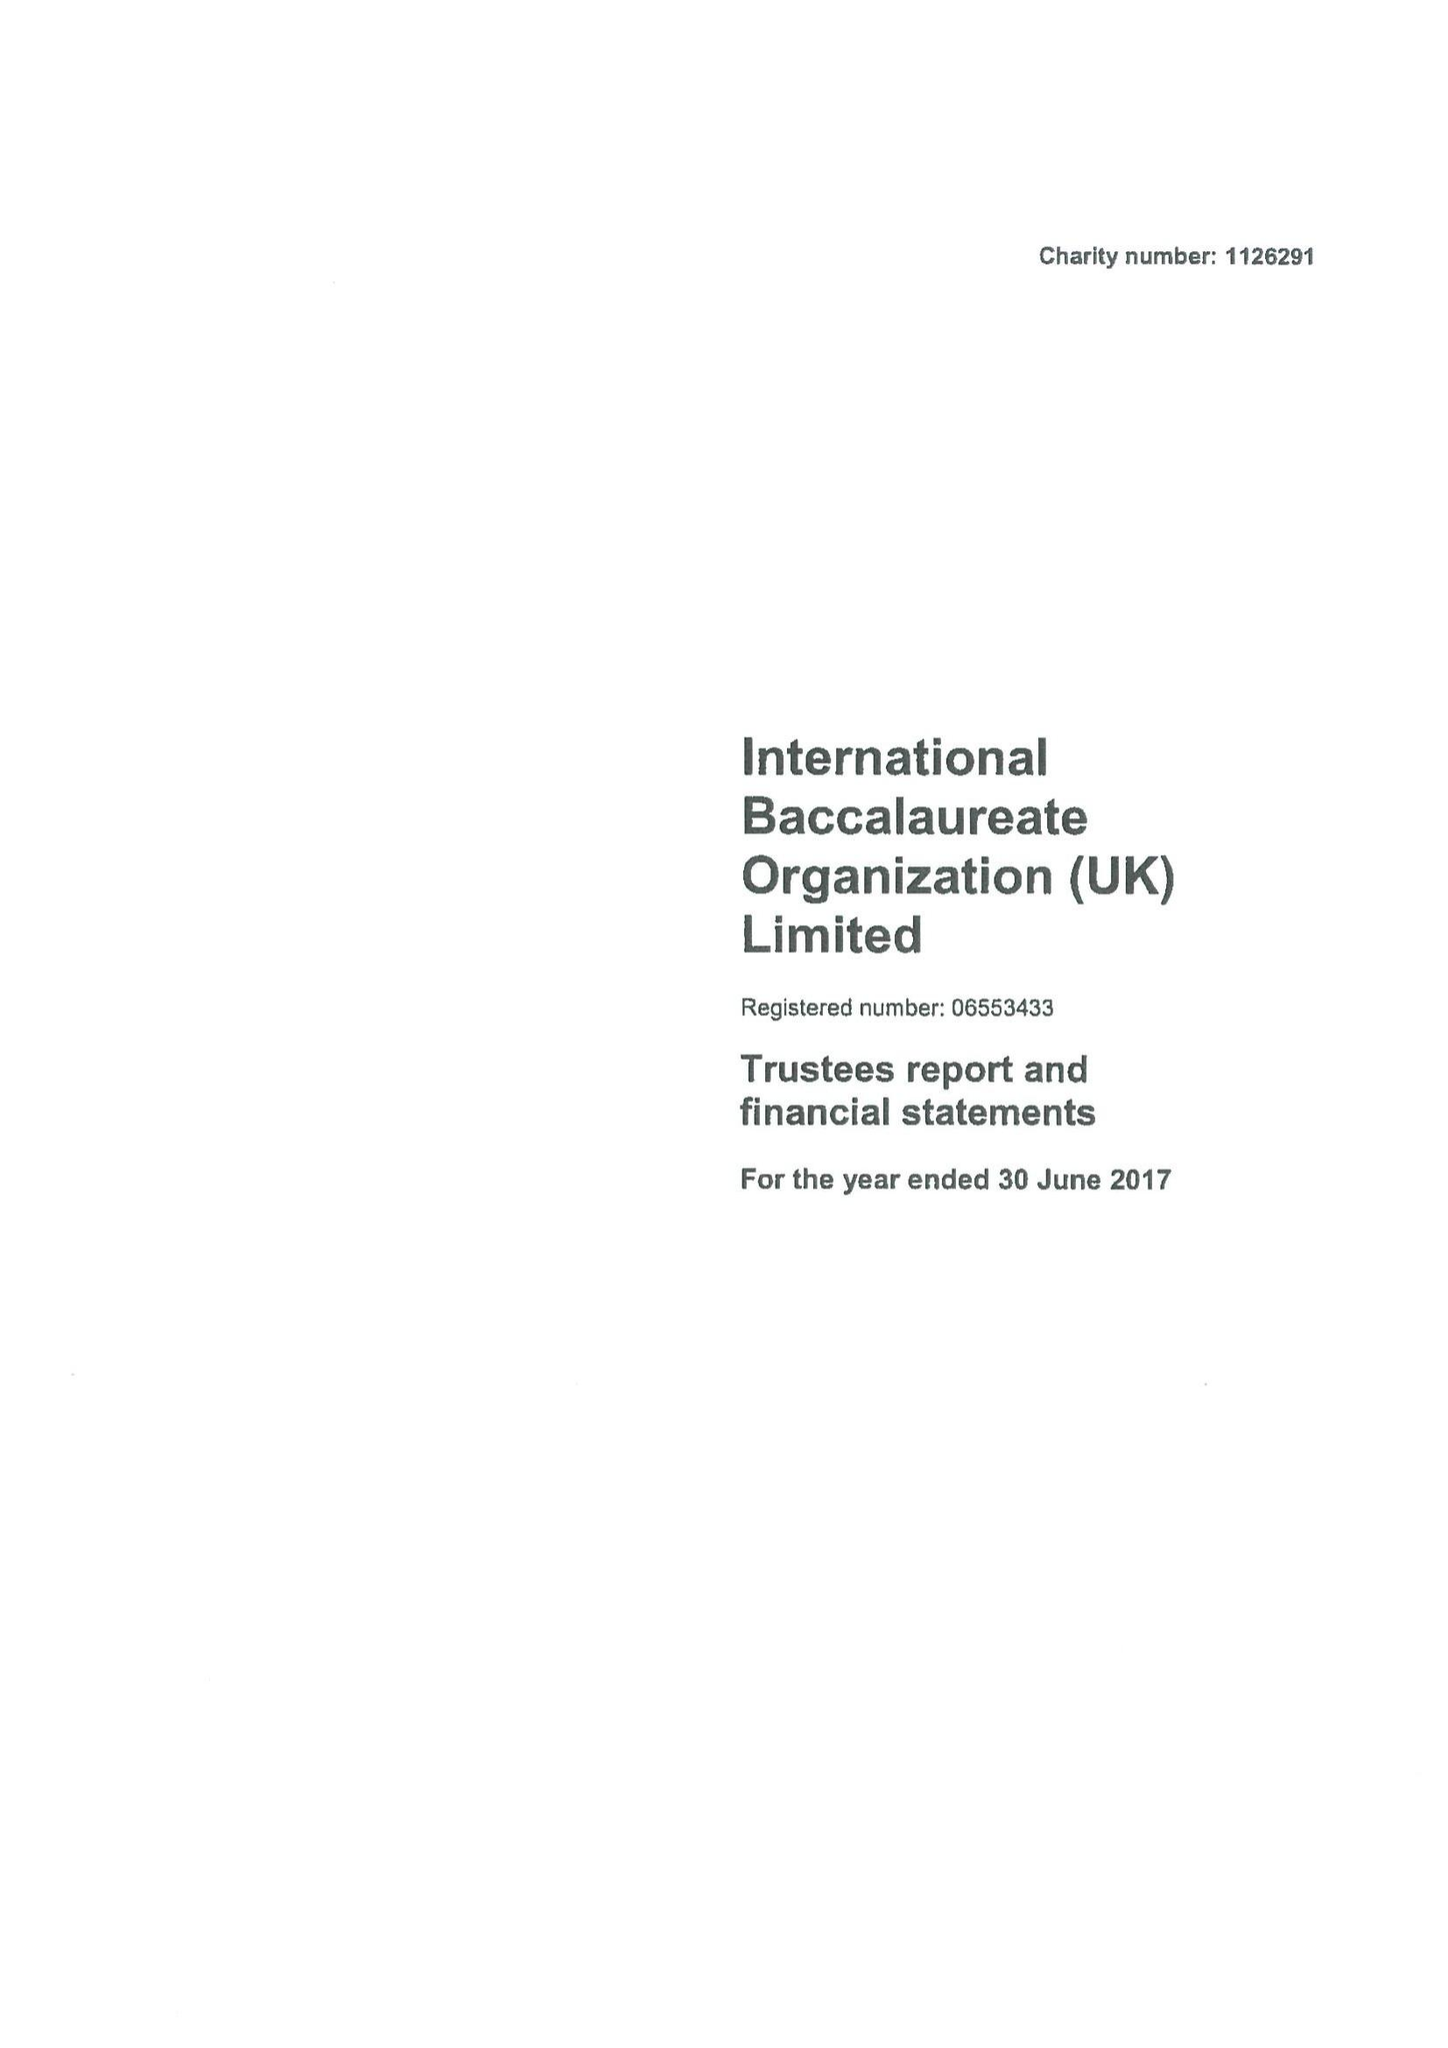What is the value for the address__street_line?
Answer the question using a single word or phrase. None 